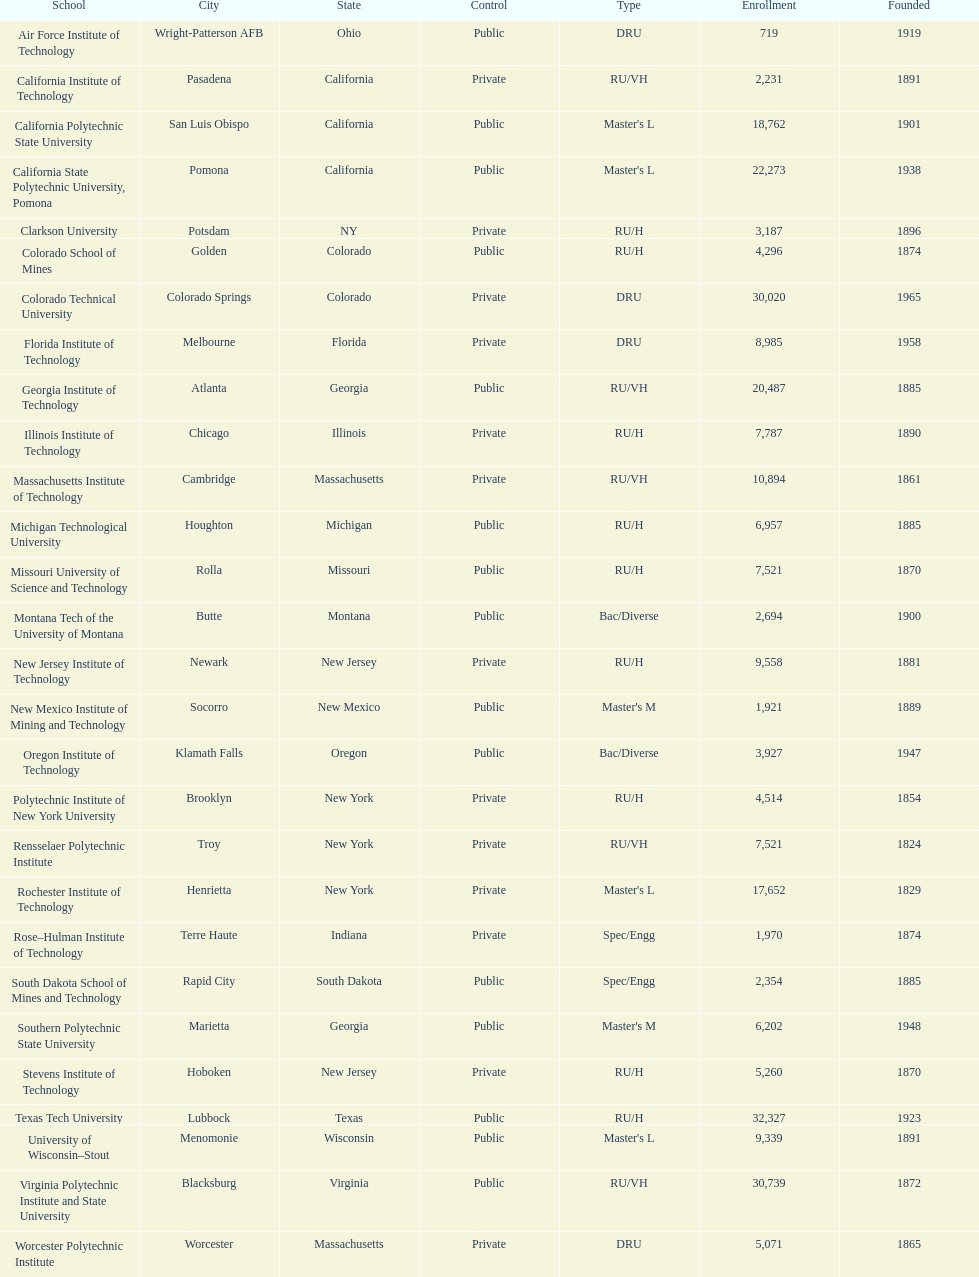How many of the universities were located in california? 3. 